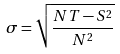Convert formula to latex. <formula><loc_0><loc_0><loc_500><loc_500>\sigma = \sqrt { \frac { N T - S ^ { 2 } } { N ^ { 2 } } }</formula> 